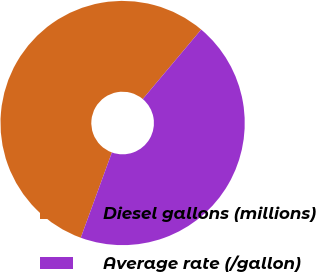Convert chart. <chart><loc_0><loc_0><loc_500><loc_500><pie_chart><fcel>Diesel gallons (millions)<fcel>Average rate (/gallon)<nl><fcel>55.56%<fcel>44.44%<nl></chart> 